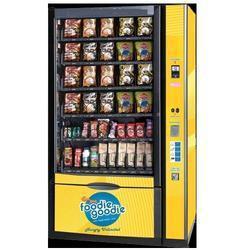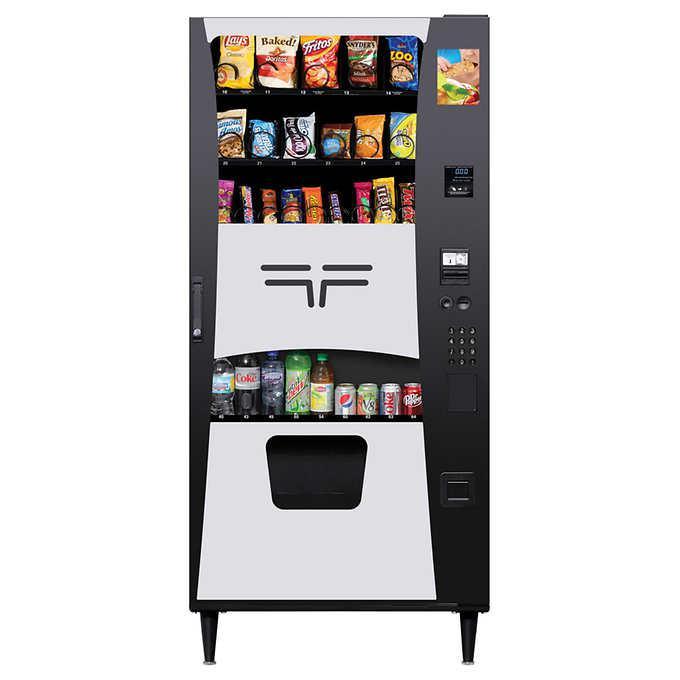The first image is the image on the left, the second image is the image on the right. Evaluate the accuracy of this statement regarding the images: "The dispensing port of the vending machine in the image on the left is outlined by a gray rectangle.". Is it true? Answer yes or no. No. 